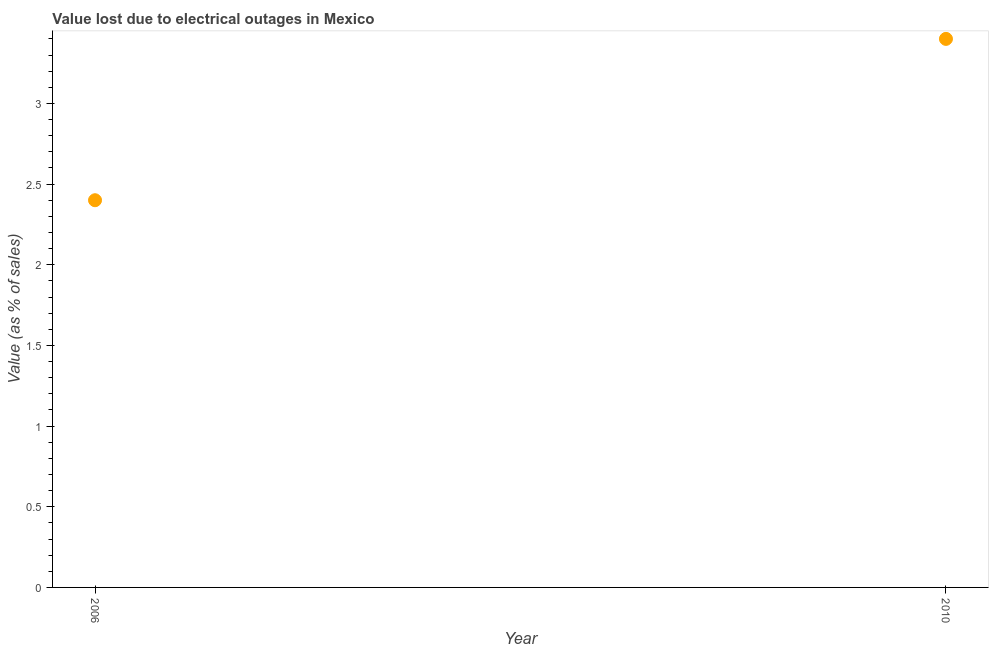Across all years, what is the minimum value lost due to electrical outages?
Ensure brevity in your answer.  2.4. In which year was the value lost due to electrical outages minimum?
Offer a terse response. 2006. What is the sum of the value lost due to electrical outages?
Give a very brief answer. 5.8. What is the difference between the value lost due to electrical outages in 2006 and 2010?
Offer a terse response. -1. What is the average value lost due to electrical outages per year?
Give a very brief answer. 2.9. What is the median value lost due to electrical outages?
Offer a terse response. 2.9. In how many years, is the value lost due to electrical outages greater than 2.2 %?
Keep it short and to the point. 2. Do a majority of the years between 2006 and 2010 (inclusive) have value lost due to electrical outages greater than 2.6 %?
Give a very brief answer. No. What is the ratio of the value lost due to electrical outages in 2006 to that in 2010?
Offer a terse response. 0.71. Is the value lost due to electrical outages in 2006 less than that in 2010?
Your answer should be very brief. Yes. In how many years, is the value lost due to electrical outages greater than the average value lost due to electrical outages taken over all years?
Provide a succinct answer. 1. What is the difference between two consecutive major ticks on the Y-axis?
Your answer should be compact. 0.5. Are the values on the major ticks of Y-axis written in scientific E-notation?
Provide a succinct answer. No. Does the graph contain any zero values?
Ensure brevity in your answer.  No. What is the title of the graph?
Provide a succinct answer. Value lost due to electrical outages in Mexico. What is the label or title of the X-axis?
Keep it short and to the point. Year. What is the label or title of the Y-axis?
Your answer should be very brief. Value (as % of sales). What is the Value (as % of sales) in 2006?
Your answer should be compact. 2.4. What is the difference between the Value (as % of sales) in 2006 and 2010?
Give a very brief answer. -1. What is the ratio of the Value (as % of sales) in 2006 to that in 2010?
Provide a succinct answer. 0.71. 